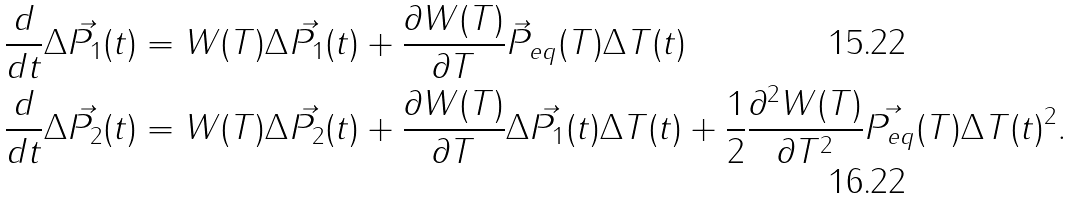Convert formula to latex. <formula><loc_0><loc_0><loc_500><loc_500>\frac { d } { d t } \Delta \vec { P _ { 1 } } ( t ) & = W ( T ) \Delta \vec { P _ { 1 } } ( t ) + \frac { \partial W ( T ) } { \partial T } \vec { P } _ { e q } ( T ) \Delta T ( t ) \\ \frac { d } { d t } \Delta \vec { P _ { 2 } } ( t ) & = W ( T ) \Delta \vec { P _ { 2 } } ( t ) + \frac { \partial W ( T ) } { \partial T } \Delta \vec { P _ { 1 } } ( t ) \Delta T ( t ) + \frac { 1 } { 2 } \frac { \partial ^ { 2 } W ( T ) } { \partial T ^ { 2 } } \vec { P _ { e q } } ( T ) \Delta T ( t ) ^ { 2 } .</formula> 